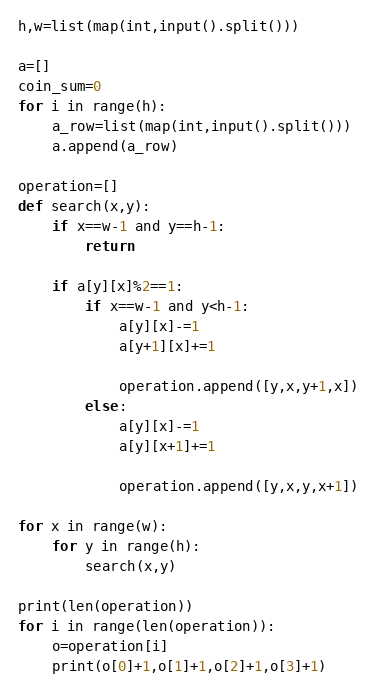Convert code to text. <code><loc_0><loc_0><loc_500><loc_500><_Python_>h,w=list(map(int,input().split()))

a=[]
coin_sum=0
for i in range(h):
    a_row=list(map(int,input().split()))
    a.append(a_row)

operation=[]
def search(x,y):
    if x==w-1 and y==h-1:
        return

    if a[y][x]%2==1:
        if x==w-1 and y<h-1:
            a[y][x]-=1
            a[y+1][x]+=1

            operation.append([y,x,y+1,x])
        else:
            a[y][x]-=1
            a[y][x+1]+=1

            operation.append([y,x,y,x+1])

for x in range(w):
    for y in range(h):
        search(x,y)

print(len(operation))
for i in range(len(operation)):
    o=operation[i]
    print(o[0]+1,o[1]+1,o[2]+1,o[3]+1)</code> 